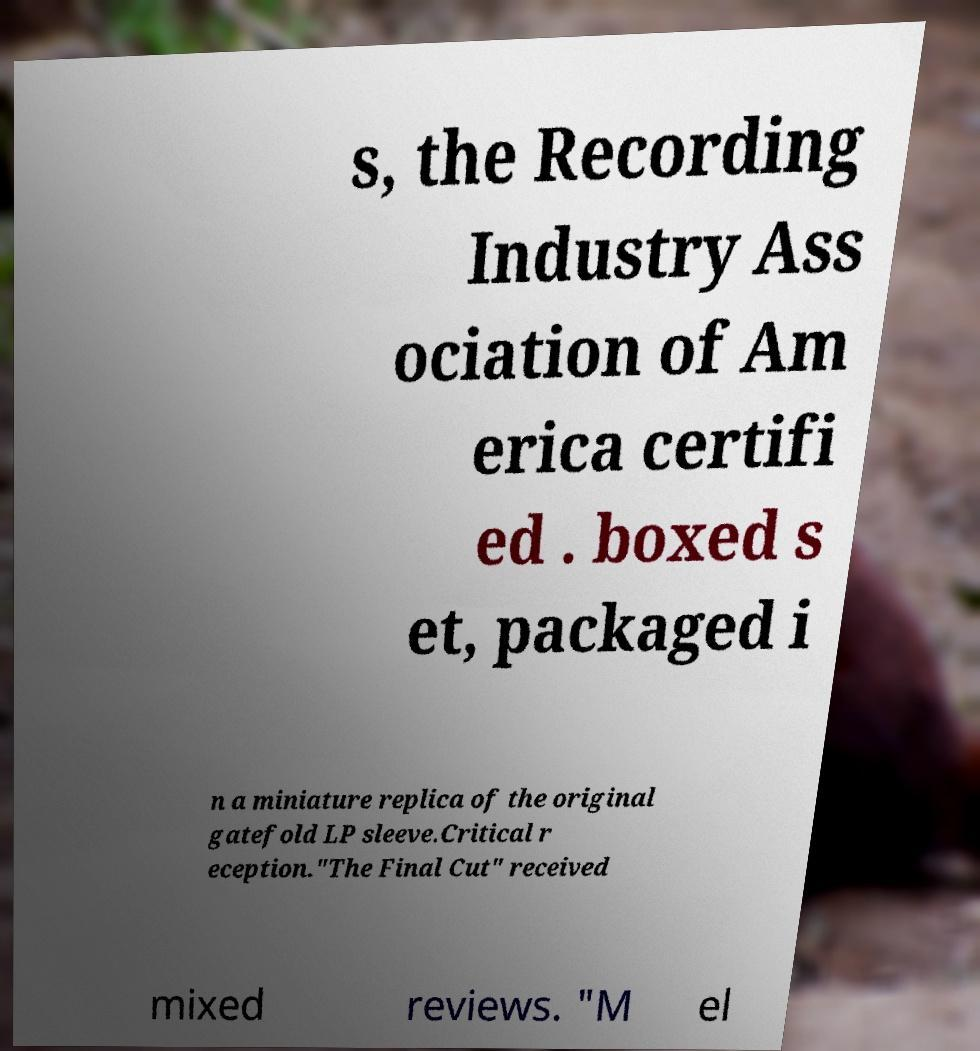Could you assist in decoding the text presented in this image and type it out clearly? s, the Recording Industry Ass ociation of Am erica certifi ed . boxed s et, packaged i n a miniature replica of the original gatefold LP sleeve.Critical r eception."The Final Cut" received mixed reviews. "M el 